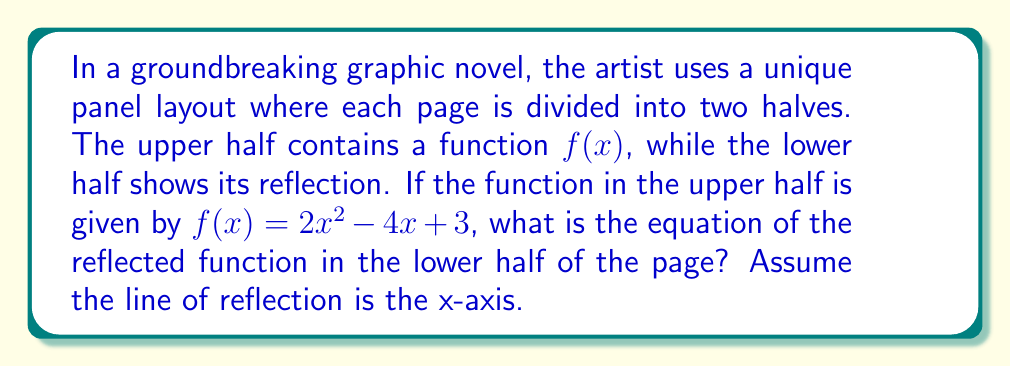Help me with this question. To find the reflection of the function $f(x) = 2x^2 - 4x + 3$ across the x-axis, we need to follow these steps:

1) The general form of a reflection across the x-axis is $g(x) = -f(x)$. This means we need to negate the entire function.

2) Start with the original function:
   $f(x) = 2x^2 - 4x + 3$

3) Negate the entire function:
   $g(x) = -(2x^2 - 4x + 3)$

4) Distribute the negative sign:
   $g(x) = -2x^2 + 4x - 3$

This resulting function $g(x) = -2x^2 + 4x - 3$ represents the reflection of the original function across the x-axis, which would appear in the lower half of the graphic novel page.

The symmetry created by this layout technique visually emphasizes the narrative duality often explored in graphic novels, providing a unique storytelling device that merges mathematical concepts with visual art.
Answer: $g(x) = -2x^2 + 4x - 3$ 